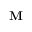<formula> <loc_0><loc_0><loc_500><loc_500>{ M }</formula> 